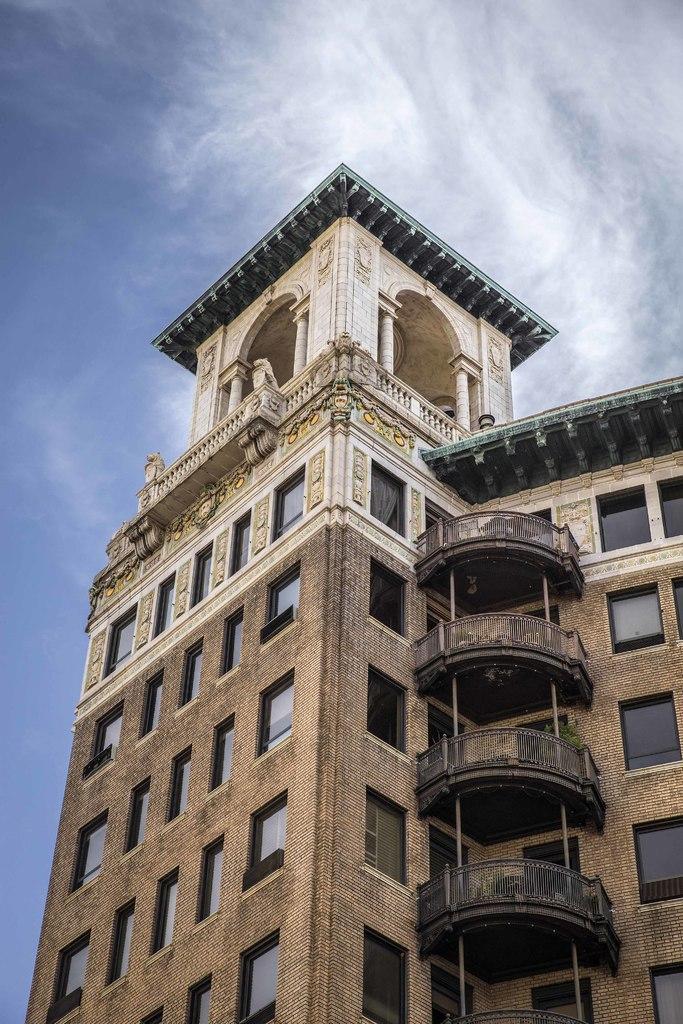Can you describe this image briefly? This picture consists of building and windows and sculpture visible on the wall of the building and at the top I can see the sky. 